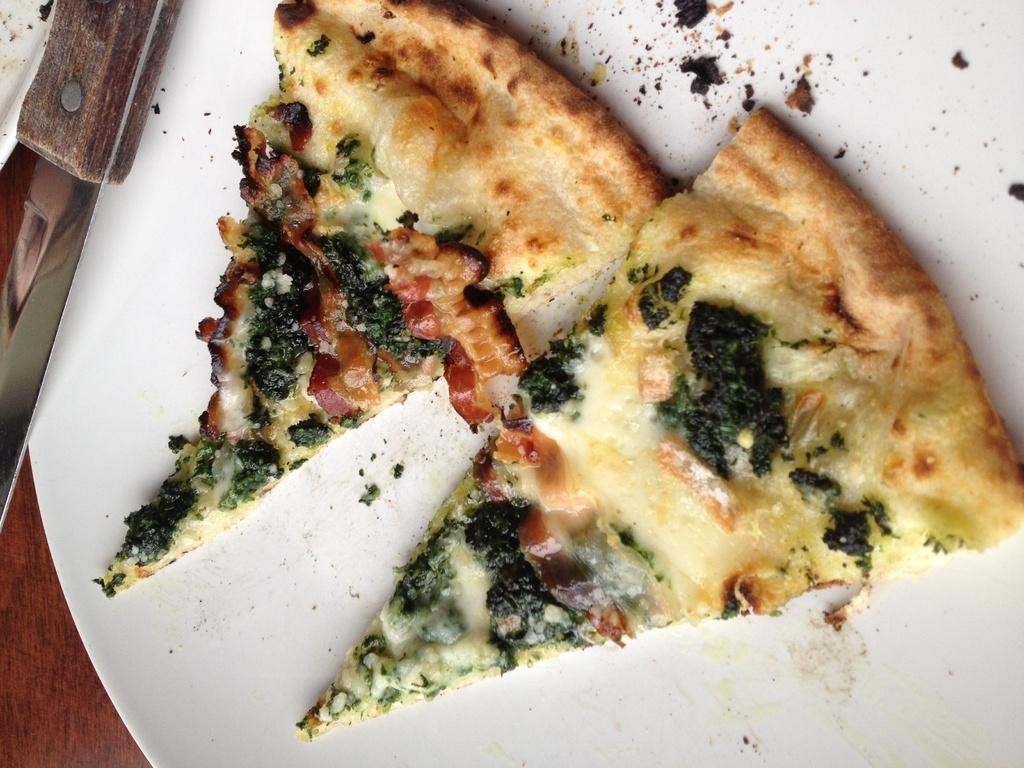What types of food items can be seen in the image? There are food items in the image, but their specific types cannot be determined without more information. What utensil is present on a plate in the image? There is a knife on a plate in the image. Can you describe the wooden object in the bottom left of the image? The wooden object in the bottom left of the image cannot be described in detail without more information. What breed of dog is sitting next to the food items in the image? There is no dog present in the image; it only contains food items, a knife on a plate, and a wooden object. What type of toothbrush is being used to cut the food items in the image? There is no toothbrush present in the image, and the knife on a plate is being used to cut the food items, not a toothbrush. 